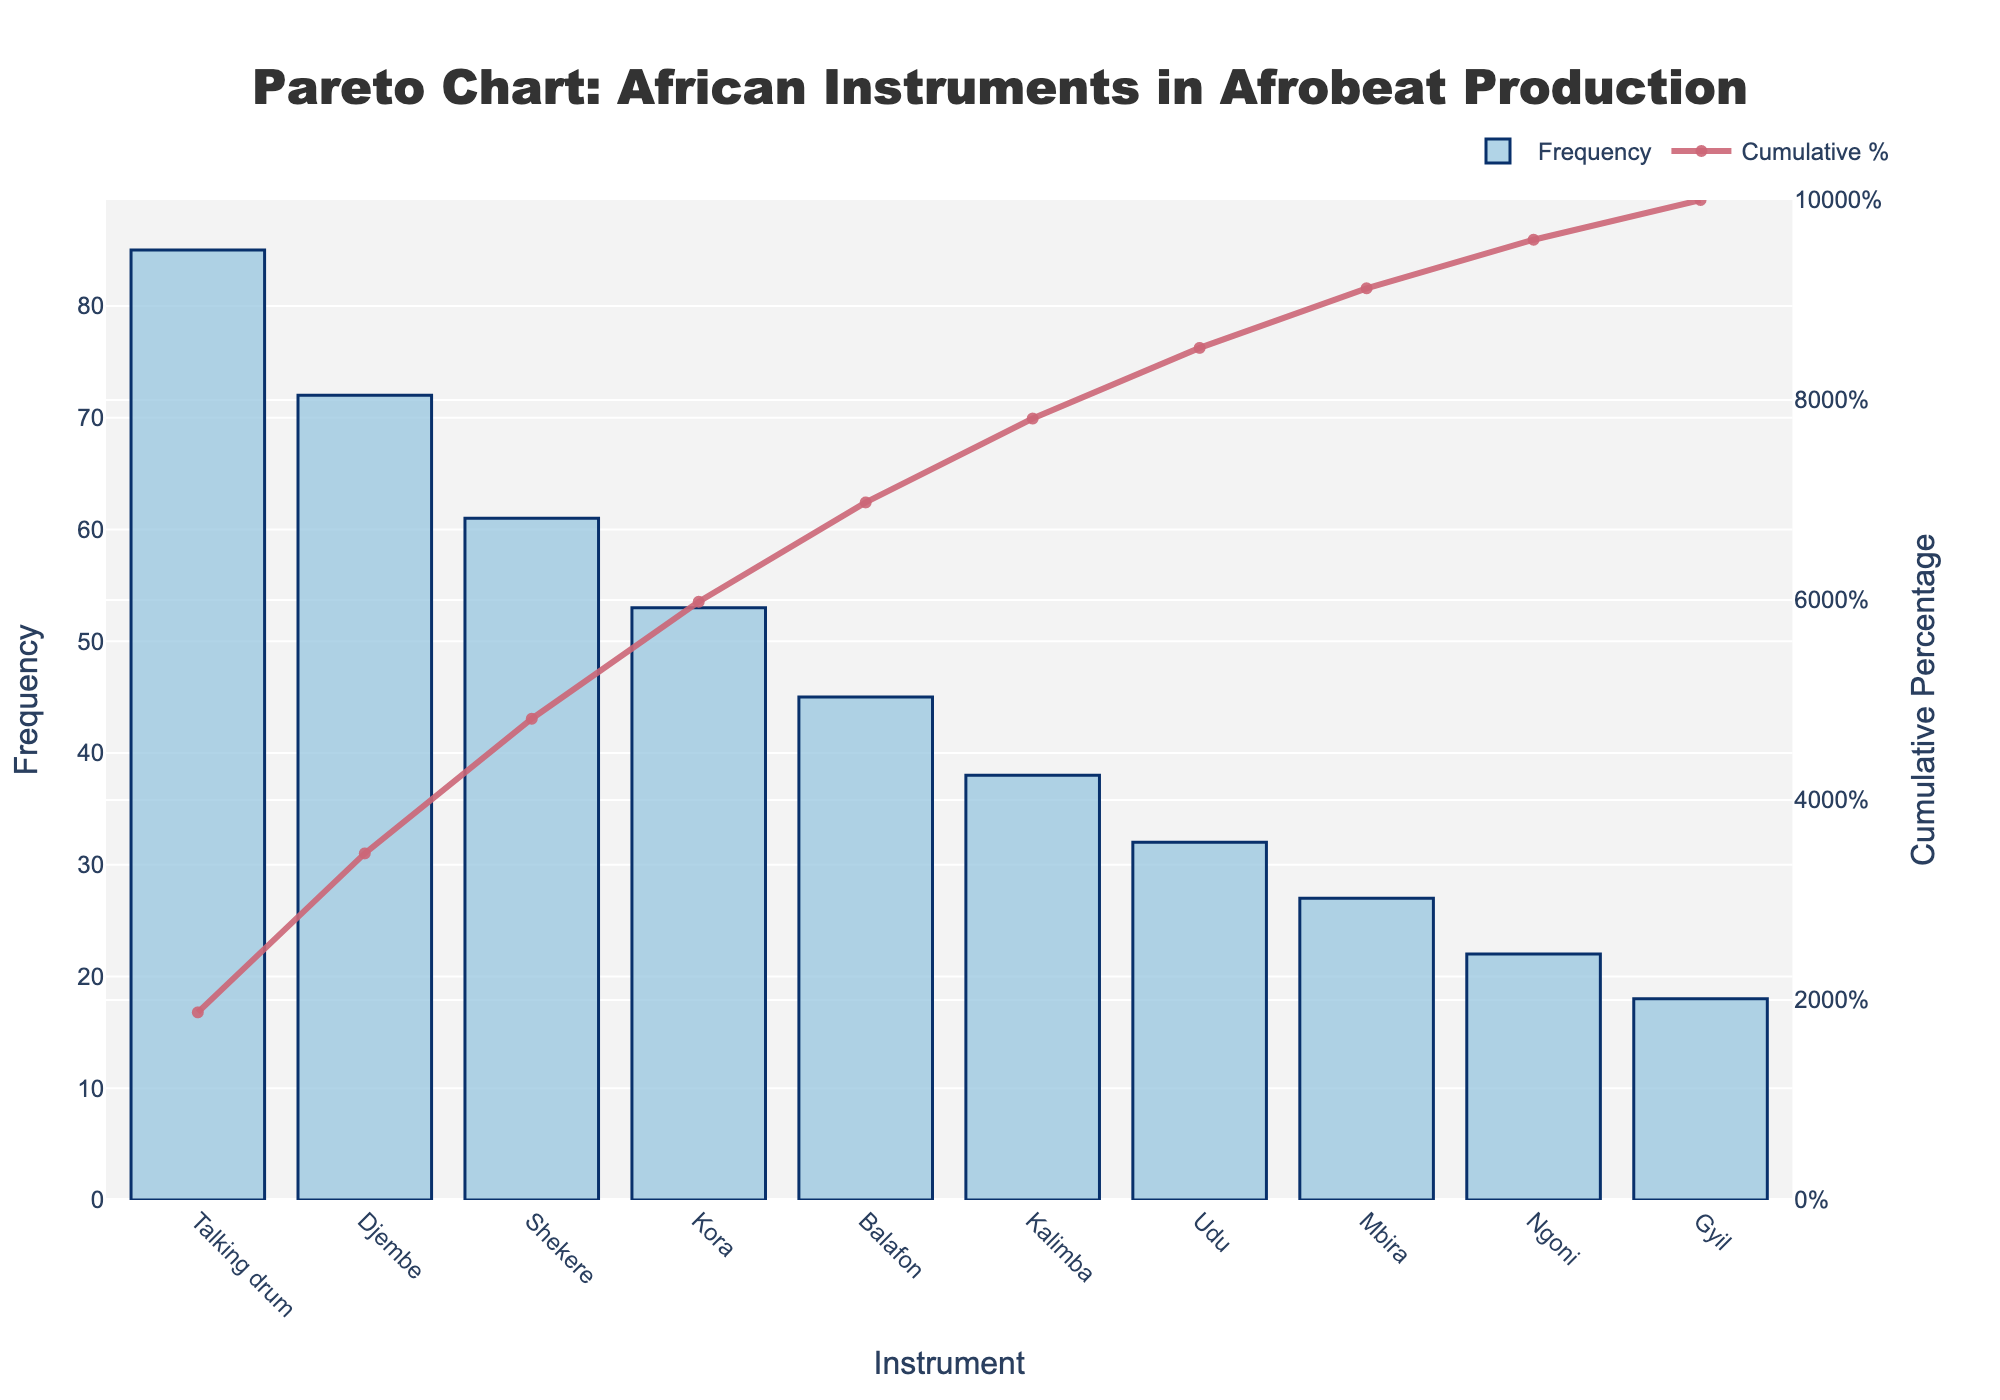What is the title of the figure? The title is located at the top of the figure, centered and in large text. It reads: "Pareto Chart: African Instruments in Afrobeat Production."
Answer: Pareto Chart: African Instruments in Afrobeat Production Which instrument has the highest frequency of use? The instrument with the highest bar in the figure represents the highest frequency. The "Talking Drum" has the highest bar, indicating the highest frequency of use among the listed instruments.
Answer: Talking Drum What is the cumulative percentage for the Balafon? The cumulative percentage is shown by the line plot. Locate the point on the line that corresponds to "Balafon" on the x-axis. This point indicates a cumulative percentage of approximately 64%.
Answer: 64% How many instruments have a usage frequency above 50? Count the number of bars that extend above the 50 mark on the y-axis. The instruments with a frequency higher than 50 are "Talking Drum," "Djembe," "Shekere," and "Kora."
Answer: 4 Which instrument ranks fifth in terms of frequency of use? Rank the instruments based on the height of their bars, from highest to lowest. The fifth instrument, based on bar height, is the "Balafon."
Answer: Balafon What is the difference in frequency between the Djembe and the Kalimba? Locate the bars corresponding to "Djembe" and "Kalimba" on the x-axis and note their heights. The Djembe has a frequency of 72, and the Kalimba has a frequency of 38. The difference is 72 - 38.
Answer: 34 What is the cumulative percentage of the top three instruments combined? The top three instruments are "Talking Drum," "Djembe," and "Shekere." Find the cumulative percentage at the "Shekere" point on the line plot. This point shows a cumulative percentage of approximately 68.4%.
Answer: 68.4% Which instrument has the lowest usage frequency, and what is its cumulative percentage? The instrument with the smallest bar is the "Gyil." The cumulative percentage at the "Gyil" point on the line plot is approximately 100%.
Answer: Gyil, 100% What is the average frequency of the listed instruments? Sum the frequencies of all instruments and divide by the number of instruments. (85 + 72 + 61 + 53 + 45 + 38 + 32 + 27 + 22 + 18) / 10 = 453 / 10.
Answer: 45.3 